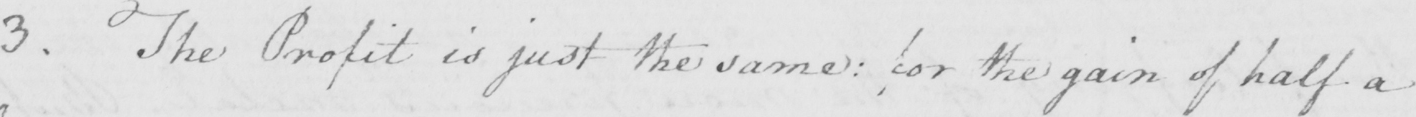Please transcribe the handwritten text in this image. 3 . The Profit is just the same :  for the gain of half a 